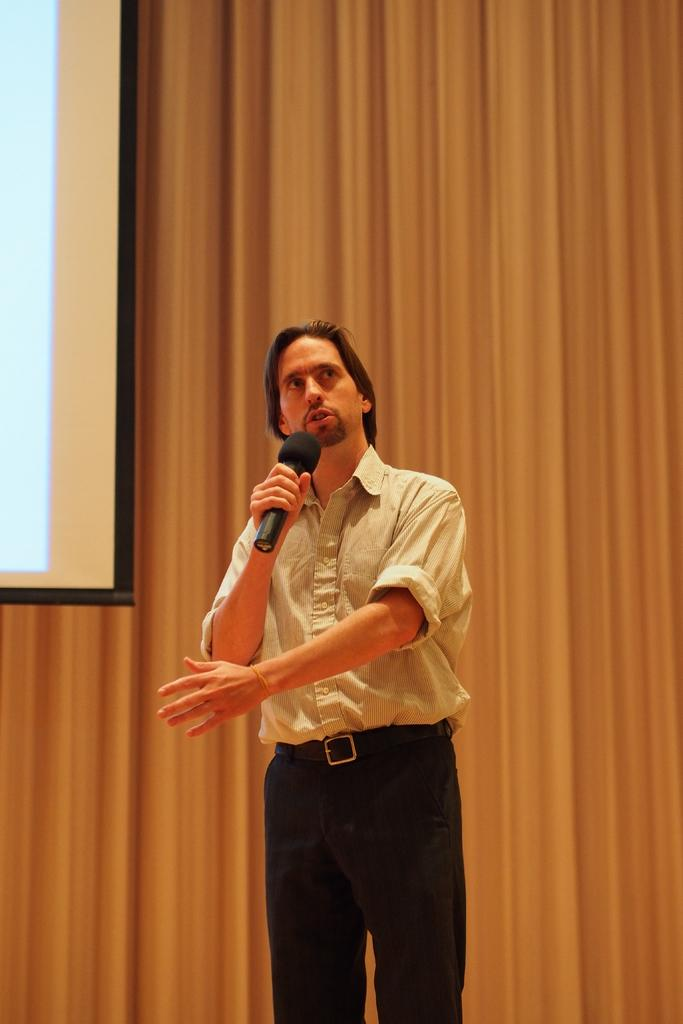What is the main subject of the image? The main subject of the image is a man. What is the man doing in the image? The man is standing and talking in the image. What is the man holding in the image? The man is holding a microphone in the image. What can be seen in the background of the image? There is a screen and a curtain in the background of the image. How many rabbits are visible on the screen in the background of the image? There are no rabbits visible on the screen in the background of the image. What type of skirt is the man wearing in the image? The man is not wearing a skirt in the image; he is wearing regular clothing. 